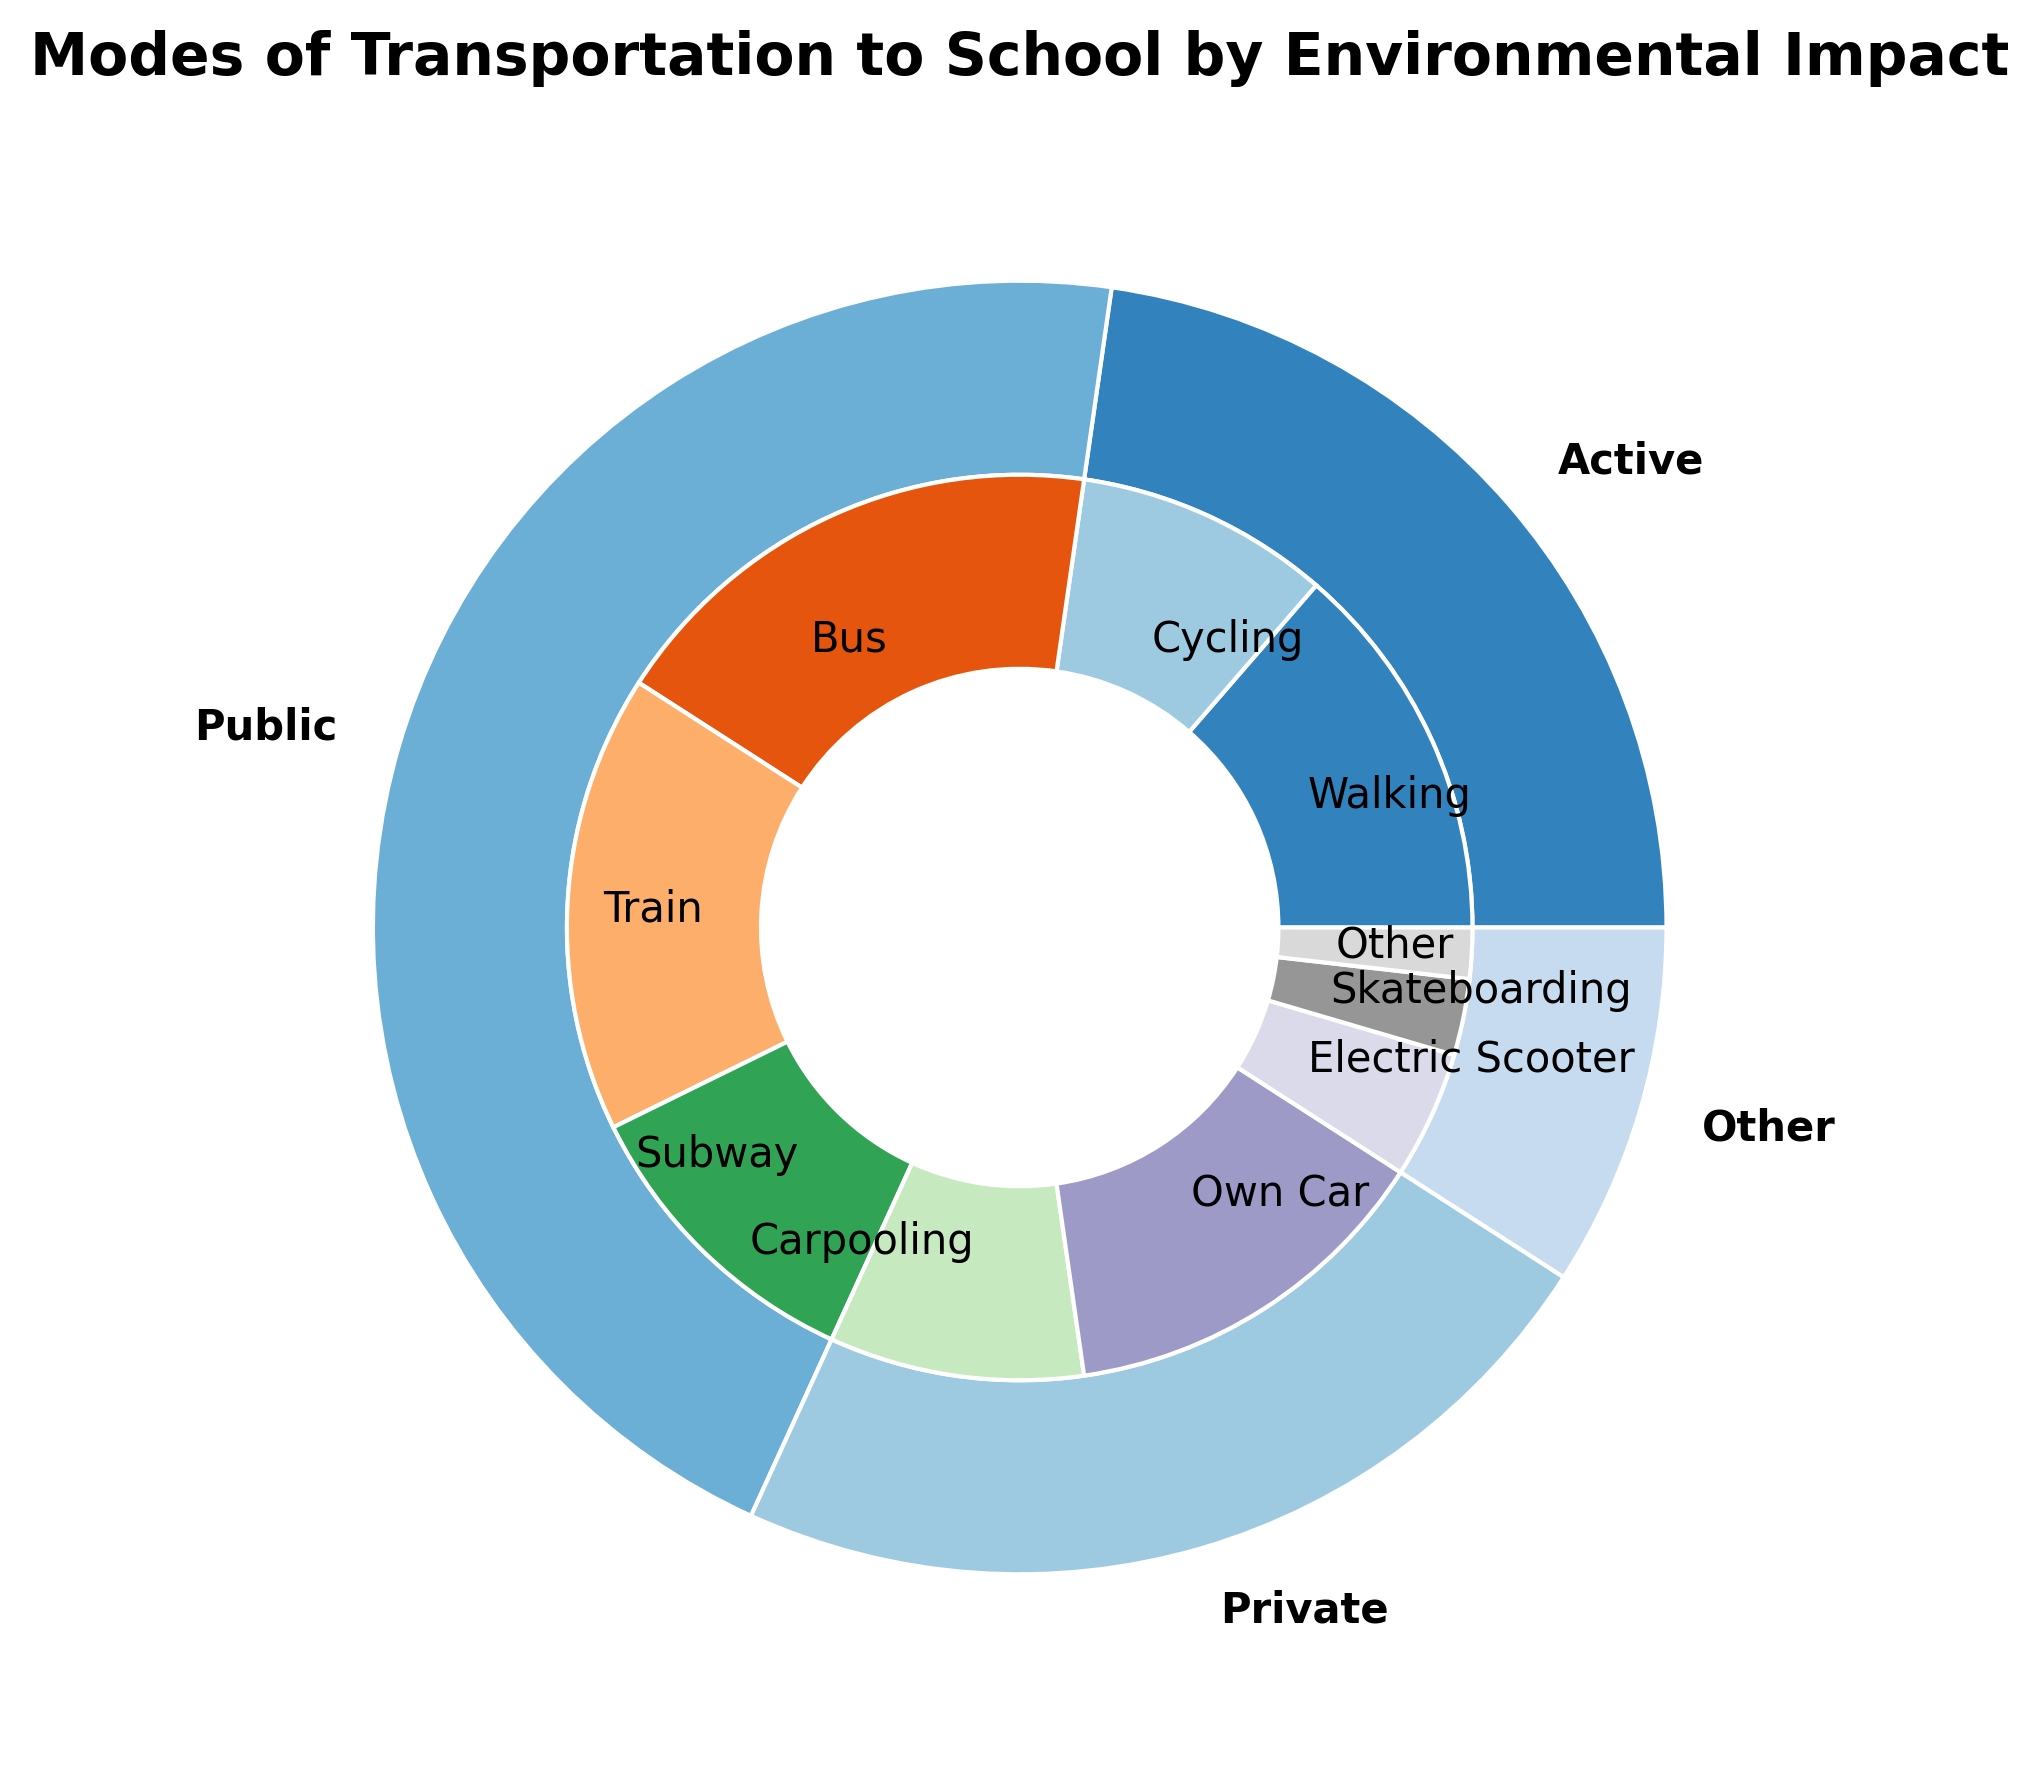Which mode of transportation has the highest percentage? Looking at the outer ring of the pie chart, the 'Public' mode of transportation appears to have the largest combined section among all the modes.
Answer: Public Which specific submode of transportation has the smallest percentage? By examining the inner ring of the pie chart, the smallest slice is labeled 'Other', which refers to the 'Other' submode with a 2% share.
Answer: Other How many more students use public transportation compared to active transportation? The percentage of students using public transportation (Bus, Train, and Subway) sums to 50%. The percentage of students using active transportation (Walking and Cycling) sums to 25%. The difference is 50% - 25% = 25%.
Answer: 25% What is the sum total percentage of students using 'Other' modes of transportation? From the inner ring, adding up the percentages of students using Electric Scooter (5%), Skateboarding (3%) and Other (2%), the sum is 5% + 3% + 2% = 10%.
Answer: 10% Is carpooling more common than walking? According to the inner ring of the pie chart, carpooling has a 10% share, while walking has a 15% share. Since 10% is less than 15%, carpooling is not more common than walking.
Answer: No Which main category has the lowest environmental impact based on the chart? 'Active' (Walking and Cycling) and 'Public' (Bus, Train, and Subway) are generally considered to have a lower environmental impact compared to 'Private'. Since both have significant portions, either can be argued as 'lowest impact'. However, often 'Active' is seen as the lowest impact.
Answer: Active How does the percentage of students using an electric scooter compare to those using their own car? Looking at the inner circle, Electric Scooter has a 5% share, and Own Car has a 15% share. Therefore, 5% is less than 15%.
Answer: Less What is the total percentage of students who use environmentally friendly modes of transportation (Active and Public combined)? Summing up the percentages of 'Active' (15% + 10% = 25%) and 'Public' (20% + 18% + 12% = 50%), the total is 25% + 50% = 75%.
Answer: 75% Among the submodes, which one has the highest percentage within the 'Public' category? Within the 'Public' category, the slices for Bus, Train, and Subway can be compared. The Bus submode, at 20%, appears to be the highest.
Answer: Bus Is skateboarding or using an electric scooter a more popular mode of transportation? By comparing the slices for Skateboarding and Electric Scooter in the inner pie chart, Skateboarding has 3%, whereas Electric Scooter has 5%. 5% is greater than 3%.
Answer: Electric Scooter 